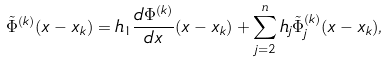<formula> <loc_0><loc_0><loc_500><loc_500>\tilde { \Phi } ^ { ( k ) } ( x - x _ { k } ) = h _ { 1 } \frac { d \Phi ^ { ( k ) } } { d x } ( x - x _ { k } ) + \sum ^ { n } _ { j = 2 } h _ { j } \tilde { \Phi } _ { j } ^ { ( k ) } ( x - x _ { k } ) ,</formula> 